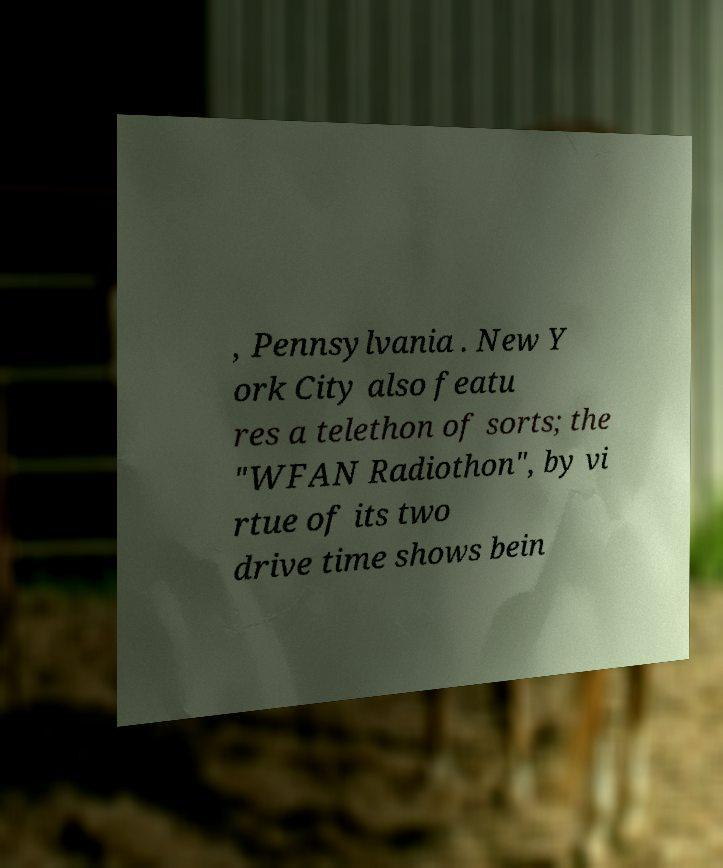Could you extract and type out the text from this image? , Pennsylvania . New Y ork City also featu res a telethon of sorts; the "WFAN Radiothon", by vi rtue of its two drive time shows bein 